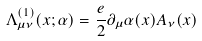<formula> <loc_0><loc_0><loc_500><loc_500>\Lambda _ { \mu \nu } ^ { ( 1 ) } ( x ; \alpha ) = \frac { e } { 2 } \partial _ { \mu } \alpha ( x ) A _ { \nu } ( x )</formula> 